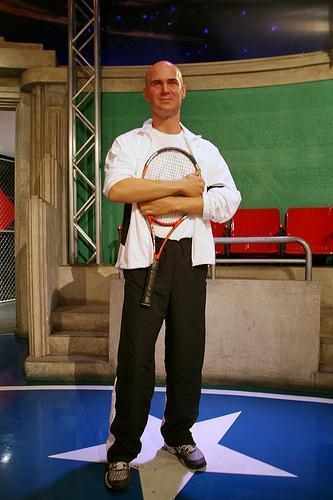How many people are in this photo?
Give a very brief answer. 1. 